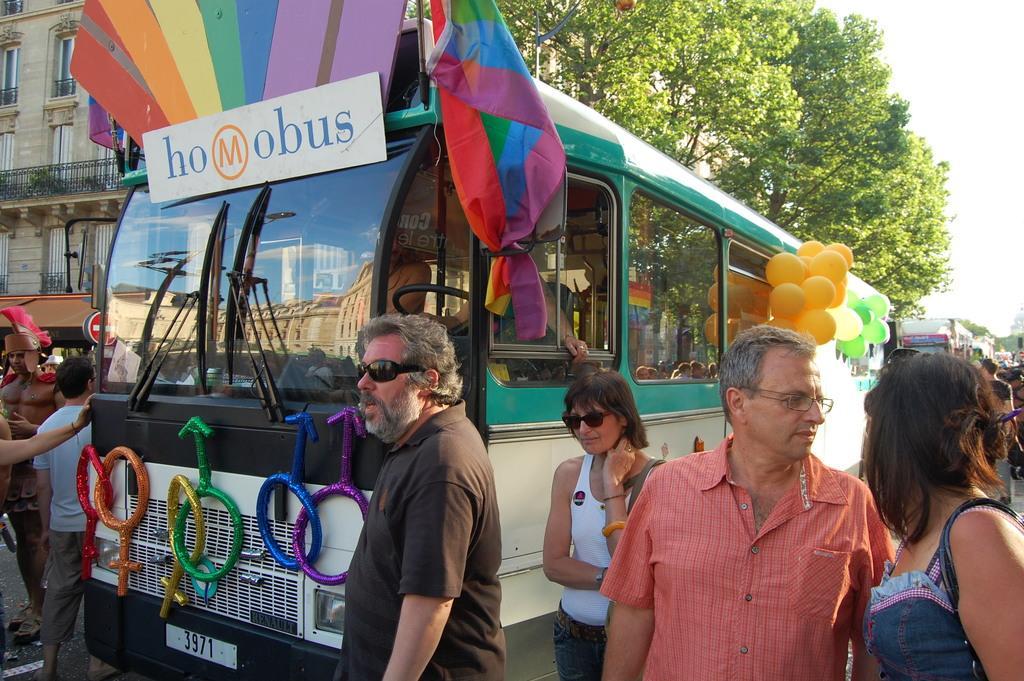Please provide a concise description of this image. In this image there is a bus in the middle. To the bus there are balloons,flags and some decorative items. In the background there are few other buses in the line. Beside the buses there are so many people who are standing and talking with each other. On the left side top there is a building. Behind the bus there is a tree. 